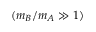Convert formula to latex. <formula><loc_0><loc_0><loc_500><loc_500>( m _ { B } / m _ { A } \gg 1 )</formula> 